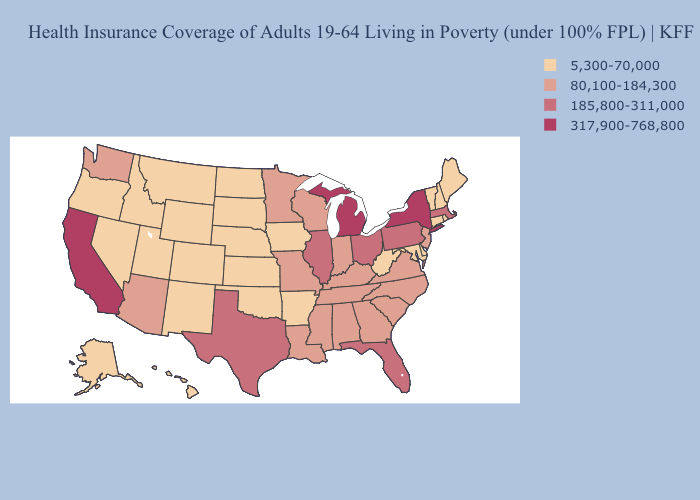Does the first symbol in the legend represent the smallest category?
Answer briefly. Yes. What is the highest value in the West ?
Write a very short answer. 317,900-768,800. What is the value of Kansas?
Short answer required. 5,300-70,000. What is the highest value in the MidWest ?
Quick response, please. 317,900-768,800. Among the states that border Connecticut , which have the lowest value?
Give a very brief answer. Rhode Island. What is the value of Pennsylvania?
Short answer required. 185,800-311,000. Does Ohio have a higher value than Massachusetts?
Be succinct. No. What is the value of North Dakota?
Concise answer only. 5,300-70,000. Among the states that border Nevada , does Idaho have the lowest value?
Give a very brief answer. Yes. Name the states that have a value in the range 185,800-311,000?
Short answer required. Florida, Illinois, Massachusetts, Ohio, Pennsylvania, Texas. Does the map have missing data?
Be succinct. No. Does the map have missing data?
Answer briefly. No. Name the states that have a value in the range 185,800-311,000?
Give a very brief answer. Florida, Illinois, Massachusetts, Ohio, Pennsylvania, Texas. Does the first symbol in the legend represent the smallest category?
Answer briefly. Yes. Does the first symbol in the legend represent the smallest category?
Quick response, please. Yes. 